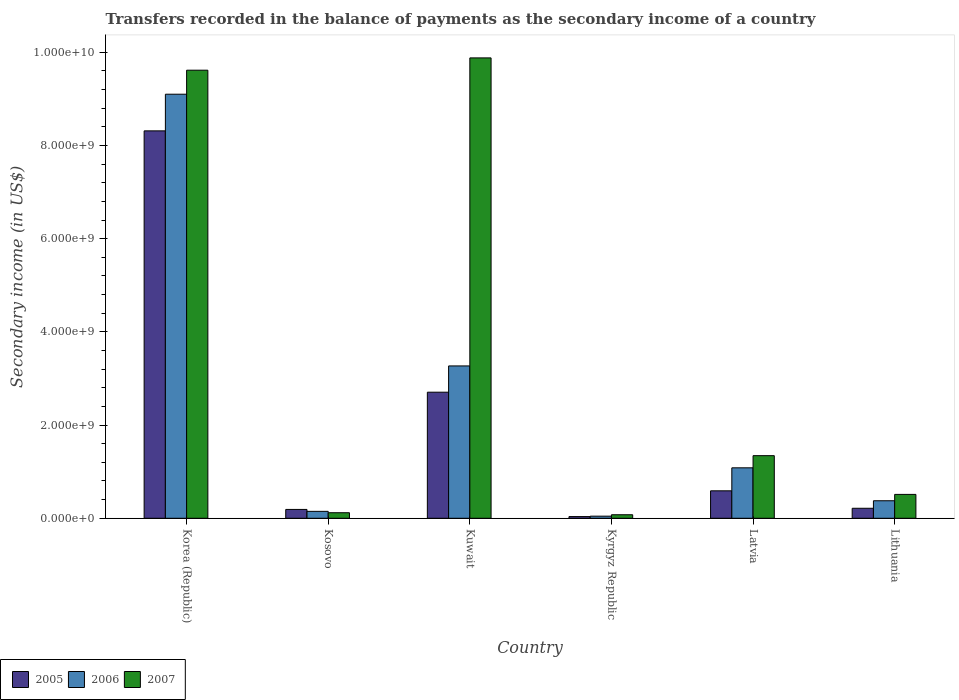How many groups of bars are there?
Make the answer very short. 6. What is the label of the 5th group of bars from the left?
Offer a very short reply. Latvia. What is the secondary income of in 2007 in Lithuania?
Provide a succinct answer. 5.12e+08. Across all countries, what is the maximum secondary income of in 2006?
Provide a short and direct response. 9.10e+09. Across all countries, what is the minimum secondary income of in 2007?
Offer a very short reply. 7.56e+07. In which country was the secondary income of in 2005 minimum?
Your answer should be compact. Kyrgyz Republic. What is the total secondary income of in 2005 in the graph?
Keep it short and to the point. 1.20e+1. What is the difference between the secondary income of in 2007 in Kosovo and that in Latvia?
Offer a very short reply. -1.22e+09. What is the difference between the secondary income of in 2007 in Latvia and the secondary income of in 2006 in Kuwait?
Offer a terse response. -1.93e+09. What is the average secondary income of in 2006 per country?
Ensure brevity in your answer.  2.34e+09. What is the difference between the secondary income of of/in 2007 and secondary income of of/in 2005 in Lithuania?
Provide a short and direct response. 2.98e+08. In how many countries, is the secondary income of in 2005 greater than 9600000000 US$?
Make the answer very short. 0. What is the ratio of the secondary income of in 2007 in Kosovo to that in Latvia?
Keep it short and to the point. 0.09. Is the secondary income of in 2006 in Korea (Republic) less than that in Kuwait?
Your response must be concise. No. What is the difference between the highest and the second highest secondary income of in 2006?
Offer a terse response. 8.02e+09. What is the difference between the highest and the lowest secondary income of in 2006?
Make the answer very short. 9.06e+09. In how many countries, is the secondary income of in 2006 greater than the average secondary income of in 2006 taken over all countries?
Offer a very short reply. 2. What does the 2nd bar from the left in Kosovo represents?
Ensure brevity in your answer.  2006. What does the 1st bar from the right in Lithuania represents?
Your answer should be very brief. 2007. Is it the case that in every country, the sum of the secondary income of in 2005 and secondary income of in 2007 is greater than the secondary income of in 2006?
Your response must be concise. Yes. How many bars are there?
Your answer should be very brief. 18. Does the graph contain any zero values?
Ensure brevity in your answer.  No. Where does the legend appear in the graph?
Keep it short and to the point. Bottom left. How are the legend labels stacked?
Your answer should be very brief. Horizontal. What is the title of the graph?
Ensure brevity in your answer.  Transfers recorded in the balance of payments as the secondary income of a country. What is the label or title of the Y-axis?
Make the answer very short. Secondary income (in US$). What is the Secondary income (in US$) in 2005 in Korea (Republic)?
Provide a short and direct response. 8.31e+09. What is the Secondary income (in US$) in 2006 in Korea (Republic)?
Your answer should be compact. 9.10e+09. What is the Secondary income (in US$) in 2007 in Korea (Republic)?
Make the answer very short. 9.62e+09. What is the Secondary income (in US$) of 2005 in Kosovo?
Your response must be concise. 1.90e+08. What is the Secondary income (in US$) in 2006 in Kosovo?
Your answer should be very brief. 1.48e+08. What is the Secondary income (in US$) in 2007 in Kosovo?
Make the answer very short. 1.19e+08. What is the Secondary income (in US$) of 2005 in Kuwait?
Provide a short and direct response. 2.71e+09. What is the Secondary income (in US$) of 2006 in Kuwait?
Make the answer very short. 3.27e+09. What is the Secondary income (in US$) of 2007 in Kuwait?
Offer a terse response. 9.88e+09. What is the Secondary income (in US$) of 2005 in Kyrgyz Republic?
Offer a very short reply. 3.63e+07. What is the Secondary income (in US$) in 2006 in Kyrgyz Republic?
Your answer should be compact. 4.53e+07. What is the Secondary income (in US$) of 2007 in Kyrgyz Republic?
Make the answer very short. 7.56e+07. What is the Secondary income (in US$) of 2005 in Latvia?
Provide a succinct answer. 5.89e+08. What is the Secondary income (in US$) in 2006 in Latvia?
Provide a short and direct response. 1.08e+09. What is the Secondary income (in US$) of 2007 in Latvia?
Your answer should be very brief. 1.34e+09. What is the Secondary income (in US$) of 2005 in Lithuania?
Your answer should be very brief. 2.14e+08. What is the Secondary income (in US$) in 2006 in Lithuania?
Offer a very short reply. 3.76e+08. What is the Secondary income (in US$) of 2007 in Lithuania?
Your answer should be compact. 5.12e+08. Across all countries, what is the maximum Secondary income (in US$) of 2005?
Ensure brevity in your answer.  8.31e+09. Across all countries, what is the maximum Secondary income (in US$) in 2006?
Your answer should be compact. 9.10e+09. Across all countries, what is the maximum Secondary income (in US$) in 2007?
Keep it short and to the point. 9.88e+09. Across all countries, what is the minimum Secondary income (in US$) in 2005?
Provide a succinct answer. 3.63e+07. Across all countries, what is the minimum Secondary income (in US$) in 2006?
Ensure brevity in your answer.  4.53e+07. Across all countries, what is the minimum Secondary income (in US$) of 2007?
Offer a terse response. 7.56e+07. What is the total Secondary income (in US$) of 2005 in the graph?
Offer a very short reply. 1.20e+1. What is the total Secondary income (in US$) in 2006 in the graph?
Ensure brevity in your answer.  1.40e+1. What is the total Secondary income (in US$) in 2007 in the graph?
Ensure brevity in your answer.  2.15e+1. What is the difference between the Secondary income (in US$) of 2005 in Korea (Republic) and that in Kosovo?
Give a very brief answer. 8.12e+09. What is the difference between the Secondary income (in US$) of 2006 in Korea (Republic) and that in Kosovo?
Make the answer very short. 8.95e+09. What is the difference between the Secondary income (in US$) of 2007 in Korea (Republic) and that in Kosovo?
Provide a short and direct response. 9.50e+09. What is the difference between the Secondary income (in US$) in 2005 in Korea (Republic) and that in Kuwait?
Offer a terse response. 5.61e+09. What is the difference between the Secondary income (in US$) in 2006 in Korea (Republic) and that in Kuwait?
Your answer should be compact. 5.83e+09. What is the difference between the Secondary income (in US$) of 2007 in Korea (Republic) and that in Kuwait?
Give a very brief answer. -2.64e+08. What is the difference between the Secondary income (in US$) in 2005 in Korea (Republic) and that in Kyrgyz Republic?
Ensure brevity in your answer.  8.28e+09. What is the difference between the Secondary income (in US$) in 2006 in Korea (Republic) and that in Kyrgyz Republic?
Offer a terse response. 9.06e+09. What is the difference between the Secondary income (in US$) of 2007 in Korea (Republic) and that in Kyrgyz Republic?
Offer a terse response. 9.54e+09. What is the difference between the Secondary income (in US$) in 2005 in Korea (Republic) and that in Latvia?
Your response must be concise. 7.72e+09. What is the difference between the Secondary income (in US$) in 2006 in Korea (Republic) and that in Latvia?
Ensure brevity in your answer.  8.02e+09. What is the difference between the Secondary income (in US$) of 2007 in Korea (Republic) and that in Latvia?
Your answer should be compact. 8.27e+09. What is the difference between the Secondary income (in US$) in 2005 in Korea (Republic) and that in Lithuania?
Offer a terse response. 8.10e+09. What is the difference between the Secondary income (in US$) of 2006 in Korea (Republic) and that in Lithuania?
Offer a very short reply. 8.72e+09. What is the difference between the Secondary income (in US$) in 2007 in Korea (Republic) and that in Lithuania?
Your response must be concise. 9.10e+09. What is the difference between the Secondary income (in US$) of 2005 in Kosovo and that in Kuwait?
Provide a succinct answer. -2.52e+09. What is the difference between the Secondary income (in US$) in 2006 in Kosovo and that in Kuwait?
Your answer should be compact. -3.12e+09. What is the difference between the Secondary income (in US$) in 2007 in Kosovo and that in Kuwait?
Offer a terse response. -9.76e+09. What is the difference between the Secondary income (in US$) in 2005 in Kosovo and that in Kyrgyz Republic?
Give a very brief answer. 1.53e+08. What is the difference between the Secondary income (in US$) of 2006 in Kosovo and that in Kyrgyz Republic?
Provide a succinct answer. 1.03e+08. What is the difference between the Secondary income (in US$) of 2007 in Kosovo and that in Kyrgyz Republic?
Your answer should be very brief. 4.33e+07. What is the difference between the Secondary income (in US$) of 2005 in Kosovo and that in Latvia?
Offer a very short reply. -4.00e+08. What is the difference between the Secondary income (in US$) in 2006 in Kosovo and that in Latvia?
Provide a succinct answer. -9.34e+08. What is the difference between the Secondary income (in US$) in 2007 in Kosovo and that in Latvia?
Ensure brevity in your answer.  -1.22e+09. What is the difference between the Secondary income (in US$) in 2005 in Kosovo and that in Lithuania?
Offer a terse response. -2.49e+07. What is the difference between the Secondary income (in US$) in 2006 in Kosovo and that in Lithuania?
Make the answer very short. -2.27e+08. What is the difference between the Secondary income (in US$) in 2007 in Kosovo and that in Lithuania?
Make the answer very short. -3.94e+08. What is the difference between the Secondary income (in US$) in 2005 in Kuwait and that in Kyrgyz Republic?
Offer a very short reply. 2.67e+09. What is the difference between the Secondary income (in US$) of 2006 in Kuwait and that in Kyrgyz Republic?
Make the answer very short. 3.22e+09. What is the difference between the Secondary income (in US$) of 2007 in Kuwait and that in Kyrgyz Republic?
Your answer should be very brief. 9.80e+09. What is the difference between the Secondary income (in US$) in 2005 in Kuwait and that in Latvia?
Keep it short and to the point. 2.12e+09. What is the difference between the Secondary income (in US$) of 2006 in Kuwait and that in Latvia?
Provide a succinct answer. 2.19e+09. What is the difference between the Secondary income (in US$) of 2007 in Kuwait and that in Latvia?
Ensure brevity in your answer.  8.54e+09. What is the difference between the Secondary income (in US$) of 2005 in Kuwait and that in Lithuania?
Your answer should be very brief. 2.49e+09. What is the difference between the Secondary income (in US$) in 2006 in Kuwait and that in Lithuania?
Provide a succinct answer. 2.89e+09. What is the difference between the Secondary income (in US$) in 2007 in Kuwait and that in Lithuania?
Your response must be concise. 9.37e+09. What is the difference between the Secondary income (in US$) in 2005 in Kyrgyz Republic and that in Latvia?
Offer a very short reply. -5.53e+08. What is the difference between the Secondary income (in US$) in 2006 in Kyrgyz Republic and that in Latvia?
Give a very brief answer. -1.04e+09. What is the difference between the Secondary income (in US$) in 2007 in Kyrgyz Republic and that in Latvia?
Give a very brief answer. -1.27e+09. What is the difference between the Secondary income (in US$) in 2005 in Kyrgyz Republic and that in Lithuania?
Ensure brevity in your answer.  -1.78e+08. What is the difference between the Secondary income (in US$) in 2006 in Kyrgyz Republic and that in Lithuania?
Your answer should be very brief. -3.31e+08. What is the difference between the Secondary income (in US$) of 2007 in Kyrgyz Republic and that in Lithuania?
Offer a very short reply. -4.37e+08. What is the difference between the Secondary income (in US$) in 2005 in Latvia and that in Lithuania?
Offer a very short reply. 3.75e+08. What is the difference between the Secondary income (in US$) in 2006 in Latvia and that in Lithuania?
Offer a very short reply. 7.07e+08. What is the difference between the Secondary income (in US$) in 2007 in Latvia and that in Lithuania?
Offer a terse response. 8.31e+08. What is the difference between the Secondary income (in US$) in 2005 in Korea (Republic) and the Secondary income (in US$) in 2006 in Kosovo?
Your answer should be very brief. 8.17e+09. What is the difference between the Secondary income (in US$) of 2005 in Korea (Republic) and the Secondary income (in US$) of 2007 in Kosovo?
Give a very brief answer. 8.20e+09. What is the difference between the Secondary income (in US$) in 2006 in Korea (Republic) and the Secondary income (in US$) in 2007 in Kosovo?
Give a very brief answer. 8.98e+09. What is the difference between the Secondary income (in US$) in 2005 in Korea (Republic) and the Secondary income (in US$) in 2006 in Kuwait?
Offer a terse response. 5.04e+09. What is the difference between the Secondary income (in US$) of 2005 in Korea (Republic) and the Secondary income (in US$) of 2007 in Kuwait?
Your answer should be very brief. -1.57e+09. What is the difference between the Secondary income (in US$) of 2006 in Korea (Republic) and the Secondary income (in US$) of 2007 in Kuwait?
Keep it short and to the point. -7.79e+08. What is the difference between the Secondary income (in US$) in 2005 in Korea (Republic) and the Secondary income (in US$) in 2006 in Kyrgyz Republic?
Give a very brief answer. 8.27e+09. What is the difference between the Secondary income (in US$) of 2005 in Korea (Republic) and the Secondary income (in US$) of 2007 in Kyrgyz Republic?
Make the answer very short. 8.24e+09. What is the difference between the Secondary income (in US$) of 2006 in Korea (Republic) and the Secondary income (in US$) of 2007 in Kyrgyz Republic?
Your response must be concise. 9.02e+09. What is the difference between the Secondary income (in US$) of 2005 in Korea (Republic) and the Secondary income (in US$) of 2006 in Latvia?
Make the answer very short. 7.23e+09. What is the difference between the Secondary income (in US$) of 2005 in Korea (Republic) and the Secondary income (in US$) of 2007 in Latvia?
Your answer should be compact. 6.97e+09. What is the difference between the Secondary income (in US$) of 2006 in Korea (Republic) and the Secondary income (in US$) of 2007 in Latvia?
Provide a short and direct response. 7.76e+09. What is the difference between the Secondary income (in US$) of 2005 in Korea (Republic) and the Secondary income (in US$) of 2006 in Lithuania?
Provide a succinct answer. 7.94e+09. What is the difference between the Secondary income (in US$) in 2005 in Korea (Republic) and the Secondary income (in US$) in 2007 in Lithuania?
Your answer should be very brief. 7.80e+09. What is the difference between the Secondary income (in US$) of 2006 in Korea (Republic) and the Secondary income (in US$) of 2007 in Lithuania?
Offer a terse response. 8.59e+09. What is the difference between the Secondary income (in US$) in 2005 in Kosovo and the Secondary income (in US$) in 2006 in Kuwait?
Make the answer very short. -3.08e+09. What is the difference between the Secondary income (in US$) in 2005 in Kosovo and the Secondary income (in US$) in 2007 in Kuwait?
Give a very brief answer. -9.69e+09. What is the difference between the Secondary income (in US$) of 2006 in Kosovo and the Secondary income (in US$) of 2007 in Kuwait?
Offer a very short reply. -9.73e+09. What is the difference between the Secondary income (in US$) in 2005 in Kosovo and the Secondary income (in US$) in 2006 in Kyrgyz Republic?
Ensure brevity in your answer.  1.44e+08. What is the difference between the Secondary income (in US$) in 2005 in Kosovo and the Secondary income (in US$) in 2007 in Kyrgyz Republic?
Provide a short and direct response. 1.14e+08. What is the difference between the Secondary income (in US$) of 2006 in Kosovo and the Secondary income (in US$) of 2007 in Kyrgyz Republic?
Offer a terse response. 7.29e+07. What is the difference between the Secondary income (in US$) of 2005 in Kosovo and the Secondary income (in US$) of 2006 in Latvia?
Your response must be concise. -8.93e+08. What is the difference between the Secondary income (in US$) of 2005 in Kosovo and the Secondary income (in US$) of 2007 in Latvia?
Offer a very short reply. -1.15e+09. What is the difference between the Secondary income (in US$) in 2006 in Kosovo and the Secondary income (in US$) in 2007 in Latvia?
Provide a short and direct response. -1.20e+09. What is the difference between the Secondary income (in US$) in 2005 in Kosovo and the Secondary income (in US$) in 2006 in Lithuania?
Offer a very short reply. -1.86e+08. What is the difference between the Secondary income (in US$) in 2005 in Kosovo and the Secondary income (in US$) in 2007 in Lithuania?
Offer a very short reply. -3.23e+08. What is the difference between the Secondary income (in US$) in 2006 in Kosovo and the Secondary income (in US$) in 2007 in Lithuania?
Your response must be concise. -3.64e+08. What is the difference between the Secondary income (in US$) in 2005 in Kuwait and the Secondary income (in US$) in 2006 in Kyrgyz Republic?
Your answer should be very brief. 2.66e+09. What is the difference between the Secondary income (in US$) in 2005 in Kuwait and the Secondary income (in US$) in 2007 in Kyrgyz Republic?
Provide a succinct answer. 2.63e+09. What is the difference between the Secondary income (in US$) in 2006 in Kuwait and the Secondary income (in US$) in 2007 in Kyrgyz Republic?
Ensure brevity in your answer.  3.19e+09. What is the difference between the Secondary income (in US$) in 2005 in Kuwait and the Secondary income (in US$) in 2006 in Latvia?
Your answer should be compact. 1.62e+09. What is the difference between the Secondary income (in US$) of 2005 in Kuwait and the Secondary income (in US$) of 2007 in Latvia?
Make the answer very short. 1.36e+09. What is the difference between the Secondary income (in US$) in 2006 in Kuwait and the Secondary income (in US$) in 2007 in Latvia?
Offer a very short reply. 1.93e+09. What is the difference between the Secondary income (in US$) in 2005 in Kuwait and the Secondary income (in US$) in 2006 in Lithuania?
Offer a terse response. 2.33e+09. What is the difference between the Secondary income (in US$) in 2005 in Kuwait and the Secondary income (in US$) in 2007 in Lithuania?
Your answer should be very brief. 2.19e+09. What is the difference between the Secondary income (in US$) of 2006 in Kuwait and the Secondary income (in US$) of 2007 in Lithuania?
Keep it short and to the point. 2.76e+09. What is the difference between the Secondary income (in US$) in 2005 in Kyrgyz Republic and the Secondary income (in US$) in 2006 in Latvia?
Make the answer very short. -1.05e+09. What is the difference between the Secondary income (in US$) in 2005 in Kyrgyz Republic and the Secondary income (in US$) in 2007 in Latvia?
Provide a short and direct response. -1.31e+09. What is the difference between the Secondary income (in US$) in 2006 in Kyrgyz Republic and the Secondary income (in US$) in 2007 in Latvia?
Your response must be concise. -1.30e+09. What is the difference between the Secondary income (in US$) in 2005 in Kyrgyz Republic and the Secondary income (in US$) in 2006 in Lithuania?
Your answer should be very brief. -3.39e+08. What is the difference between the Secondary income (in US$) of 2005 in Kyrgyz Republic and the Secondary income (in US$) of 2007 in Lithuania?
Your answer should be very brief. -4.76e+08. What is the difference between the Secondary income (in US$) in 2006 in Kyrgyz Republic and the Secondary income (in US$) in 2007 in Lithuania?
Keep it short and to the point. -4.67e+08. What is the difference between the Secondary income (in US$) of 2005 in Latvia and the Secondary income (in US$) of 2006 in Lithuania?
Offer a terse response. 2.13e+08. What is the difference between the Secondary income (in US$) of 2005 in Latvia and the Secondary income (in US$) of 2007 in Lithuania?
Your answer should be compact. 7.68e+07. What is the difference between the Secondary income (in US$) of 2006 in Latvia and the Secondary income (in US$) of 2007 in Lithuania?
Keep it short and to the point. 5.70e+08. What is the average Secondary income (in US$) in 2005 per country?
Ensure brevity in your answer.  2.01e+09. What is the average Secondary income (in US$) in 2006 per country?
Keep it short and to the point. 2.34e+09. What is the average Secondary income (in US$) of 2007 per country?
Provide a succinct answer. 3.59e+09. What is the difference between the Secondary income (in US$) in 2005 and Secondary income (in US$) in 2006 in Korea (Republic)?
Offer a terse response. -7.86e+08. What is the difference between the Secondary income (in US$) of 2005 and Secondary income (in US$) of 2007 in Korea (Republic)?
Give a very brief answer. -1.30e+09. What is the difference between the Secondary income (in US$) in 2006 and Secondary income (in US$) in 2007 in Korea (Republic)?
Your answer should be compact. -5.15e+08. What is the difference between the Secondary income (in US$) of 2005 and Secondary income (in US$) of 2006 in Kosovo?
Give a very brief answer. 4.11e+07. What is the difference between the Secondary income (in US$) of 2005 and Secondary income (in US$) of 2007 in Kosovo?
Your answer should be compact. 7.07e+07. What is the difference between the Secondary income (in US$) in 2006 and Secondary income (in US$) in 2007 in Kosovo?
Ensure brevity in your answer.  2.97e+07. What is the difference between the Secondary income (in US$) of 2005 and Secondary income (in US$) of 2006 in Kuwait?
Offer a terse response. -5.64e+08. What is the difference between the Secondary income (in US$) in 2005 and Secondary income (in US$) in 2007 in Kuwait?
Your answer should be very brief. -7.17e+09. What is the difference between the Secondary income (in US$) in 2006 and Secondary income (in US$) in 2007 in Kuwait?
Make the answer very short. -6.61e+09. What is the difference between the Secondary income (in US$) of 2005 and Secondary income (in US$) of 2006 in Kyrgyz Republic?
Provide a succinct answer. -8.99e+06. What is the difference between the Secondary income (in US$) in 2005 and Secondary income (in US$) in 2007 in Kyrgyz Republic?
Offer a very short reply. -3.93e+07. What is the difference between the Secondary income (in US$) of 2006 and Secondary income (in US$) of 2007 in Kyrgyz Republic?
Your answer should be very brief. -3.03e+07. What is the difference between the Secondary income (in US$) of 2005 and Secondary income (in US$) of 2006 in Latvia?
Your answer should be very brief. -4.93e+08. What is the difference between the Secondary income (in US$) of 2005 and Secondary income (in US$) of 2007 in Latvia?
Provide a short and direct response. -7.54e+08. What is the difference between the Secondary income (in US$) in 2006 and Secondary income (in US$) in 2007 in Latvia?
Keep it short and to the point. -2.61e+08. What is the difference between the Secondary income (in US$) in 2005 and Secondary income (in US$) in 2006 in Lithuania?
Your response must be concise. -1.61e+08. What is the difference between the Secondary income (in US$) in 2005 and Secondary income (in US$) in 2007 in Lithuania?
Provide a short and direct response. -2.98e+08. What is the difference between the Secondary income (in US$) in 2006 and Secondary income (in US$) in 2007 in Lithuania?
Make the answer very short. -1.37e+08. What is the ratio of the Secondary income (in US$) of 2005 in Korea (Republic) to that in Kosovo?
Your answer should be very brief. 43.86. What is the ratio of the Secondary income (in US$) in 2006 in Korea (Republic) to that in Kosovo?
Ensure brevity in your answer.  61.28. What is the ratio of the Secondary income (in US$) of 2007 in Korea (Republic) to that in Kosovo?
Provide a succinct answer. 80.91. What is the ratio of the Secondary income (in US$) of 2005 in Korea (Republic) to that in Kuwait?
Keep it short and to the point. 3.07. What is the ratio of the Secondary income (in US$) in 2006 in Korea (Republic) to that in Kuwait?
Make the answer very short. 2.78. What is the ratio of the Secondary income (in US$) of 2007 in Korea (Republic) to that in Kuwait?
Keep it short and to the point. 0.97. What is the ratio of the Secondary income (in US$) in 2005 in Korea (Republic) to that in Kyrgyz Republic?
Provide a short and direct response. 229.19. What is the ratio of the Secondary income (in US$) of 2006 in Korea (Republic) to that in Kyrgyz Republic?
Provide a succinct answer. 201.05. What is the ratio of the Secondary income (in US$) of 2007 in Korea (Republic) to that in Kyrgyz Republic?
Your answer should be very brief. 127.26. What is the ratio of the Secondary income (in US$) in 2005 in Korea (Republic) to that in Latvia?
Provide a succinct answer. 14.11. What is the ratio of the Secondary income (in US$) of 2006 in Korea (Republic) to that in Latvia?
Offer a very short reply. 8.41. What is the ratio of the Secondary income (in US$) in 2007 in Korea (Republic) to that in Latvia?
Keep it short and to the point. 7.16. What is the ratio of the Secondary income (in US$) in 2005 in Korea (Republic) to that in Lithuania?
Offer a terse response. 38.77. What is the ratio of the Secondary income (in US$) in 2006 in Korea (Republic) to that in Lithuania?
Provide a short and direct response. 24.22. What is the ratio of the Secondary income (in US$) in 2007 in Korea (Republic) to that in Lithuania?
Your response must be concise. 18.77. What is the ratio of the Secondary income (in US$) in 2005 in Kosovo to that in Kuwait?
Give a very brief answer. 0.07. What is the ratio of the Secondary income (in US$) of 2006 in Kosovo to that in Kuwait?
Ensure brevity in your answer.  0.05. What is the ratio of the Secondary income (in US$) in 2007 in Kosovo to that in Kuwait?
Your answer should be compact. 0.01. What is the ratio of the Secondary income (in US$) in 2005 in Kosovo to that in Kyrgyz Republic?
Your response must be concise. 5.23. What is the ratio of the Secondary income (in US$) of 2006 in Kosovo to that in Kyrgyz Republic?
Make the answer very short. 3.28. What is the ratio of the Secondary income (in US$) of 2007 in Kosovo to that in Kyrgyz Republic?
Provide a short and direct response. 1.57. What is the ratio of the Secondary income (in US$) of 2005 in Kosovo to that in Latvia?
Your response must be concise. 0.32. What is the ratio of the Secondary income (in US$) of 2006 in Kosovo to that in Latvia?
Your answer should be very brief. 0.14. What is the ratio of the Secondary income (in US$) in 2007 in Kosovo to that in Latvia?
Offer a very short reply. 0.09. What is the ratio of the Secondary income (in US$) in 2005 in Kosovo to that in Lithuania?
Give a very brief answer. 0.88. What is the ratio of the Secondary income (in US$) in 2006 in Kosovo to that in Lithuania?
Provide a short and direct response. 0.4. What is the ratio of the Secondary income (in US$) of 2007 in Kosovo to that in Lithuania?
Your answer should be very brief. 0.23. What is the ratio of the Secondary income (in US$) in 2005 in Kuwait to that in Kyrgyz Republic?
Provide a succinct answer. 74.58. What is the ratio of the Secondary income (in US$) of 2006 in Kuwait to that in Kyrgyz Republic?
Offer a terse response. 72.23. What is the ratio of the Secondary income (in US$) in 2007 in Kuwait to that in Kyrgyz Republic?
Give a very brief answer. 130.76. What is the ratio of the Secondary income (in US$) of 2005 in Kuwait to that in Latvia?
Give a very brief answer. 4.59. What is the ratio of the Secondary income (in US$) in 2006 in Kuwait to that in Latvia?
Make the answer very short. 3.02. What is the ratio of the Secondary income (in US$) of 2007 in Kuwait to that in Latvia?
Your response must be concise. 7.35. What is the ratio of the Secondary income (in US$) in 2005 in Kuwait to that in Lithuania?
Your answer should be very brief. 12.62. What is the ratio of the Secondary income (in US$) in 2006 in Kuwait to that in Lithuania?
Your answer should be compact. 8.7. What is the ratio of the Secondary income (in US$) of 2007 in Kuwait to that in Lithuania?
Make the answer very short. 19.28. What is the ratio of the Secondary income (in US$) in 2005 in Kyrgyz Republic to that in Latvia?
Give a very brief answer. 0.06. What is the ratio of the Secondary income (in US$) in 2006 in Kyrgyz Republic to that in Latvia?
Offer a terse response. 0.04. What is the ratio of the Secondary income (in US$) of 2007 in Kyrgyz Republic to that in Latvia?
Offer a very short reply. 0.06. What is the ratio of the Secondary income (in US$) in 2005 in Kyrgyz Republic to that in Lithuania?
Offer a terse response. 0.17. What is the ratio of the Secondary income (in US$) in 2006 in Kyrgyz Republic to that in Lithuania?
Keep it short and to the point. 0.12. What is the ratio of the Secondary income (in US$) in 2007 in Kyrgyz Republic to that in Lithuania?
Your response must be concise. 0.15. What is the ratio of the Secondary income (in US$) in 2005 in Latvia to that in Lithuania?
Offer a terse response. 2.75. What is the ratio of the Secondary income (in US$) of 2006 in Latvia to that in Lithuania?
Ensure brevity in your answer.  2.88. What is the ratio of the Secondary income (in US$) of 2007 in Latvia to that in Lithuania?
Your answer should be very brief. 2.62. What is the difference between the highest and the second highest Secondary income (in US$) of 2005?
Your answer should be compact. 5.61e+09. What is the difference between the highest and the second highest Secondary income (in US$) in 2006?
Your answer should be very brief. 5.83e+09. What is the difference between the highest and the second highest Secondary income (in US$) in 2007?
Offer a terse response. 2.64e+08. What is the difference between the highest and the lowest Secondary income (in US$) in 2005?
Provide a short and direct response. 8.28e+09. What is the difference between the highest and the lowest Secondary income (in US$) of 2006?
Ensure brevity in your answer.  9.06e+09. What is the difference between the highest and the lowest Secondary income (in US$) in 2007?
Your answer should be compact. 9.80e+09. 